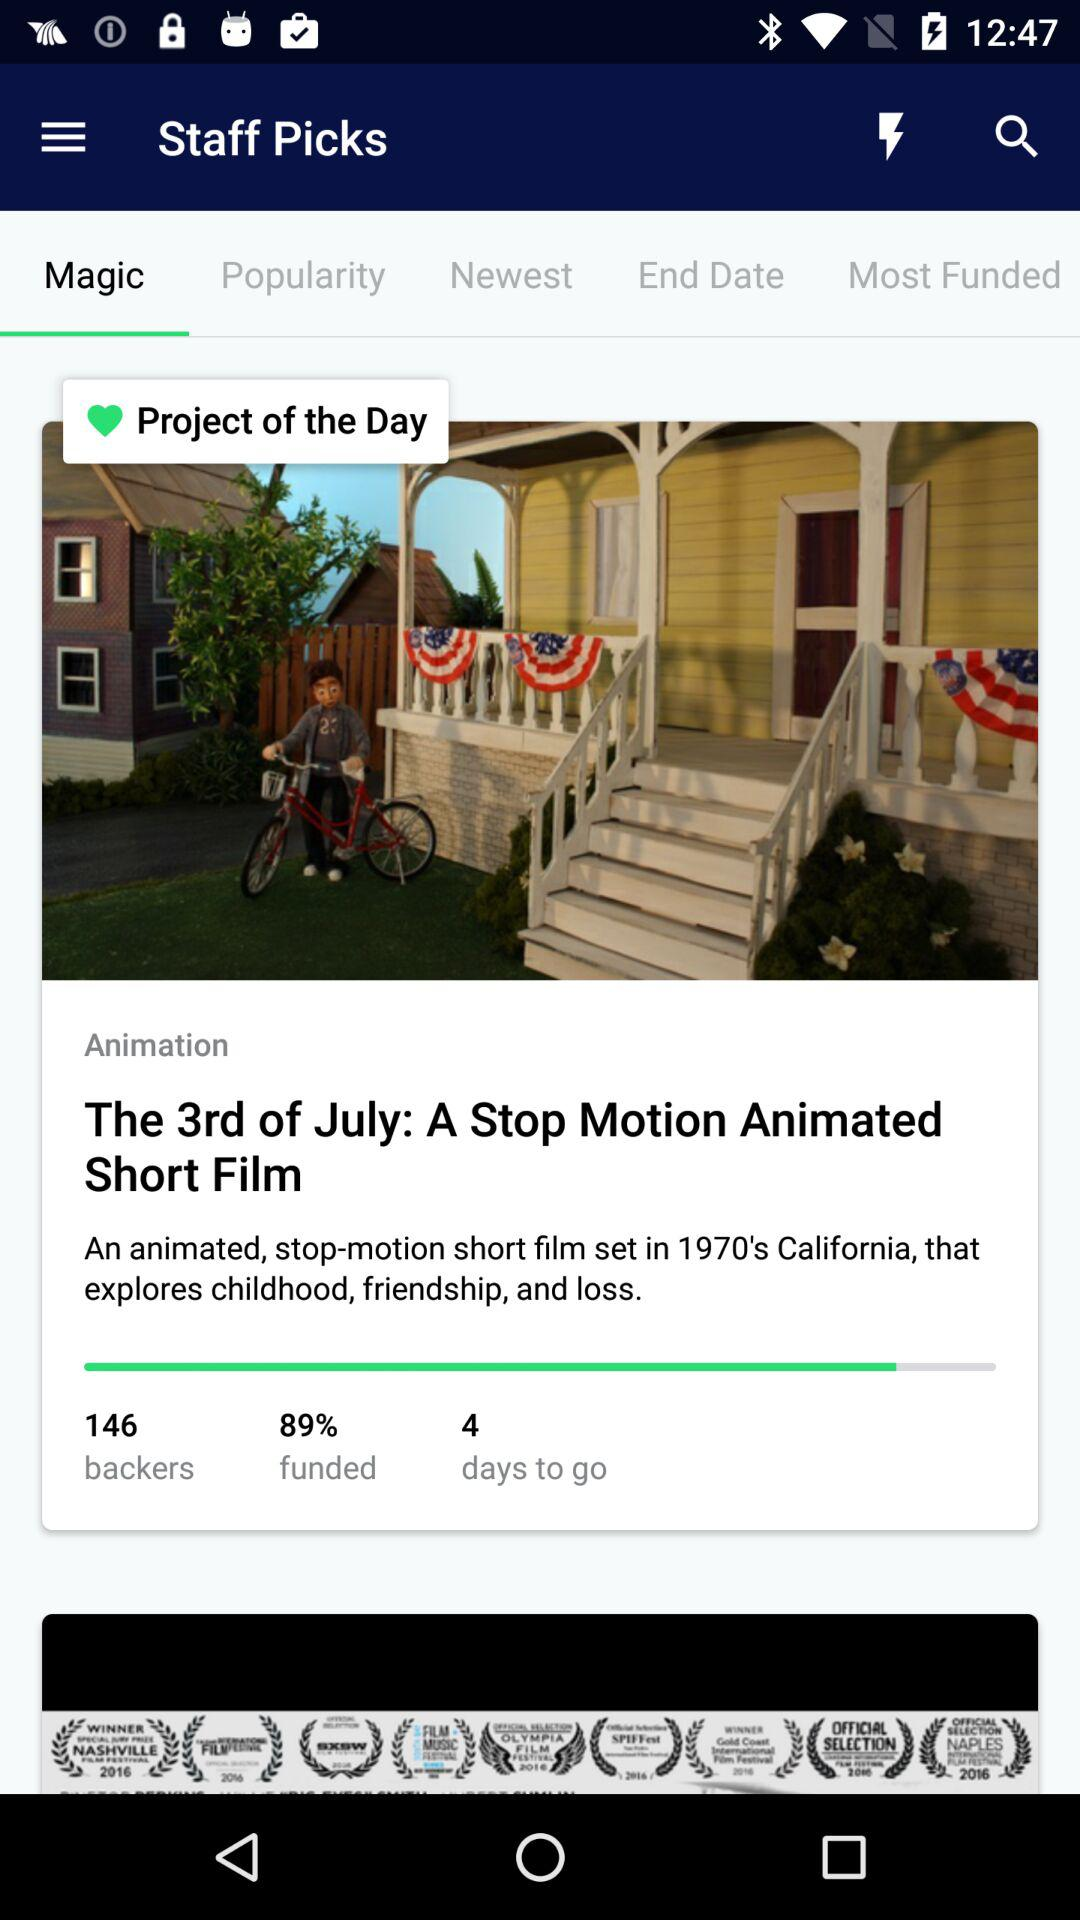What is the funding percentage? The funding percentage is 89. 